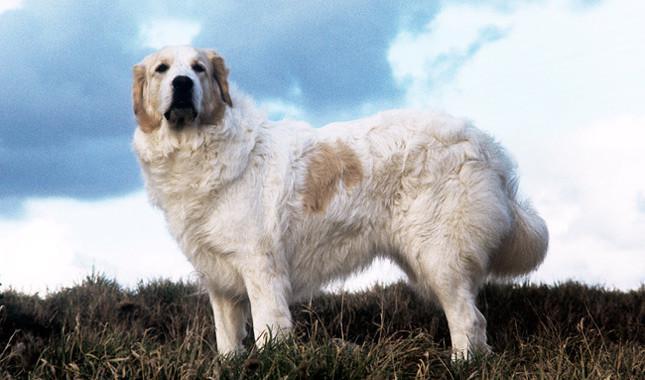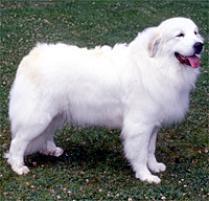The first image is the image on the left, the second image is the image on the right. For the images displayed, is the sentence "A large white dog, standing at an outdoor location, has its mouth open and is showing its tongue." factually correct? Answer yes or no. Yes. The first image is the image on the left, the second image is the image on the right. Given the left and right images, does the statement "The dog on the right is standing in the grass." hold true? Answer yes or no. Yes. 